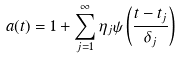<formula> <loc_0><loc_0><loc_500><loc_500>a ( t ) = 1 + \sum _ { j = 1 } ^ { \infty } \eta _ { j } \psi \left ( \frac { t - t _ { j } } { \delta _ { j } } \right )</formula> 